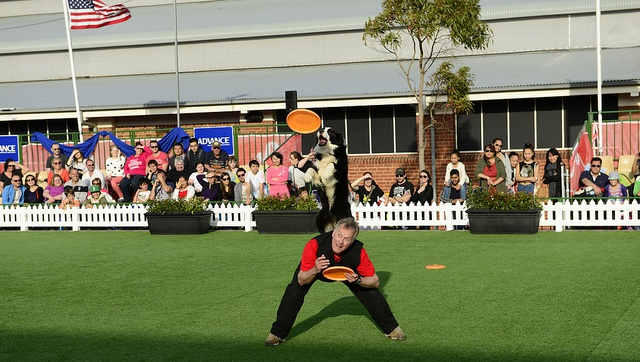Describe the objects in this image and their specific colors. I can see people in black, ivory, tan, and gray tones, people in black, red, gray, and olive tones, dog in black, tan, and gray tones, people in black, darkgreen, gray, and brown tones, and people in black, gray, and tan tones in this image. 